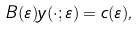<formula> <loc_0><loc_0><loc_500><loc_500>B ( \varepsilon ) y ( \cdot ; \varepsilon ) = c ( \varepsilon ) ,</formula> 